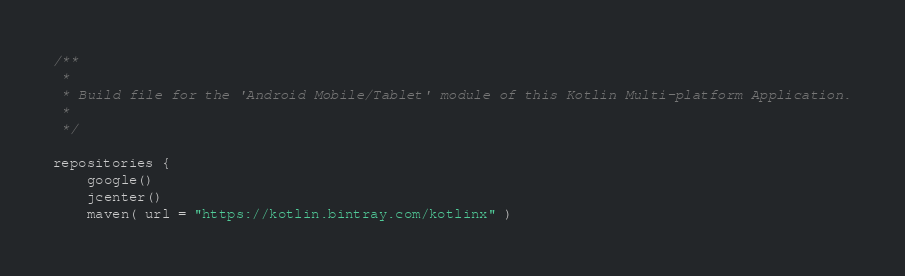Convert code to text. <code><loc_0><loc_0><loc_500><loc_500><_Kotlin_>
/**
 *
 * Build file for the 'Android Mobile/Tablet' module of this Kotlin Multi-platform Application.
 *
 */

repositories {
    google()
    jcenter()
    maven( url = "https://kotlin.bintray.com/kotlinx" )</code> 